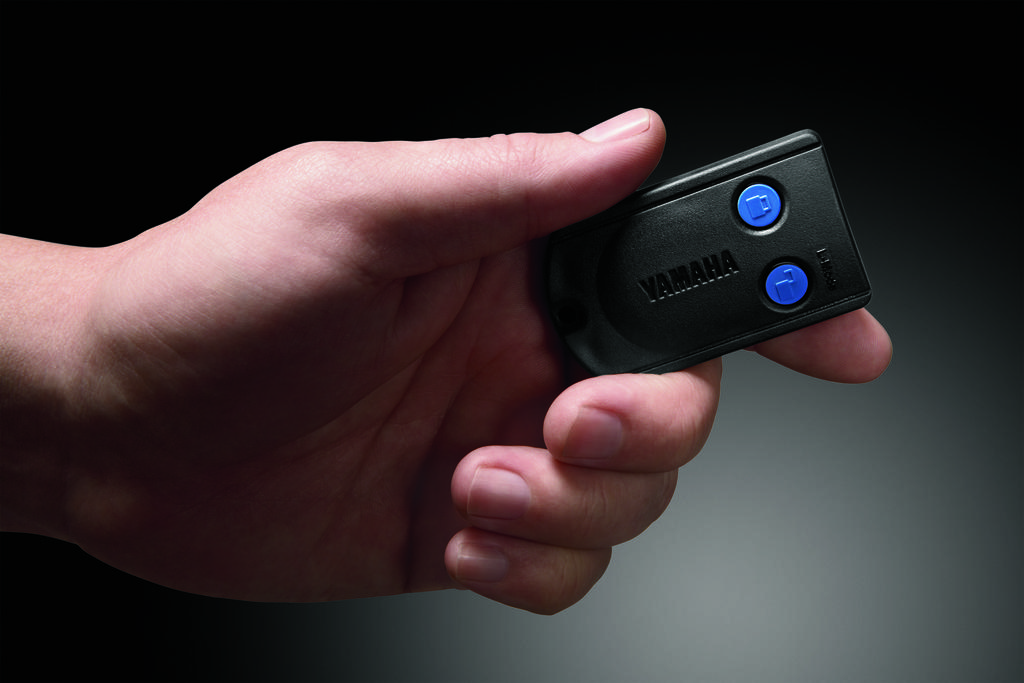What is the main subject of the image? There is a person in the image. What is the person doing in the image? The person's hand is holding a device. Can you describe the background of the image? The background of the image is dark. What type of news can be seen on the ornament in the yard in the image? There is no ornament or yard present in the image, and therefore no news can be seen. 